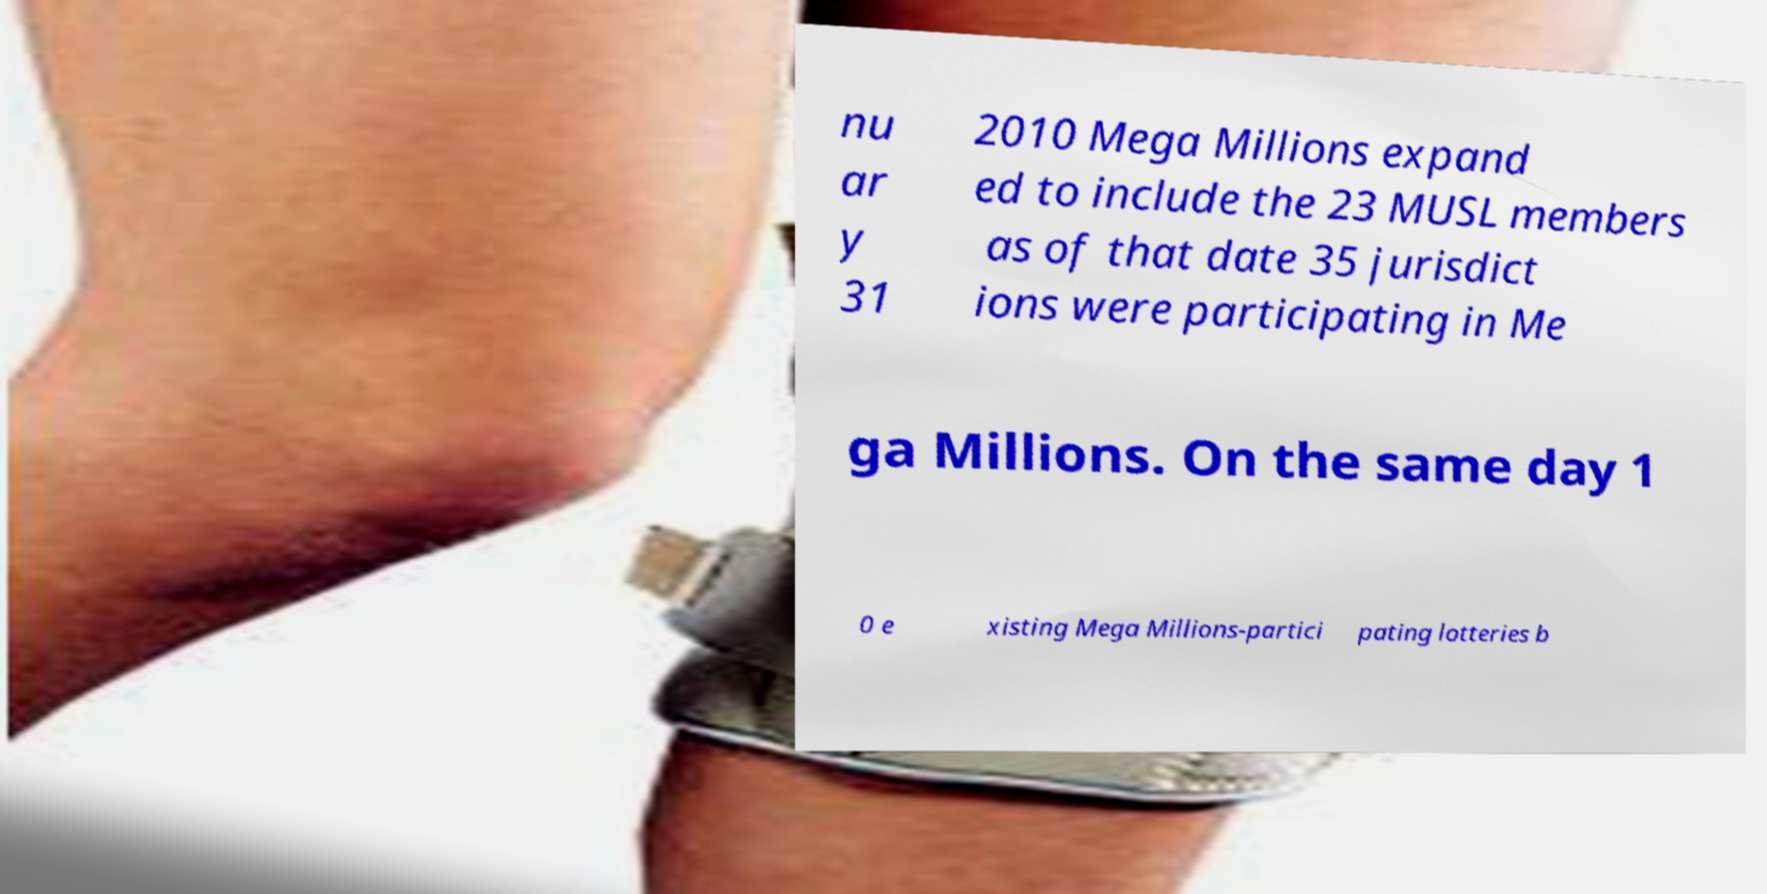Please read and relay the text visible in this image. What does it say? nu ar y 31 2010 Mega Millions expand ed to include the 23 MUSL members as of that date 35 jurisdict ions were participating in Me ga Millions. On the same day 1 0 e xisting Mega Millions-partici pating lotteries b 